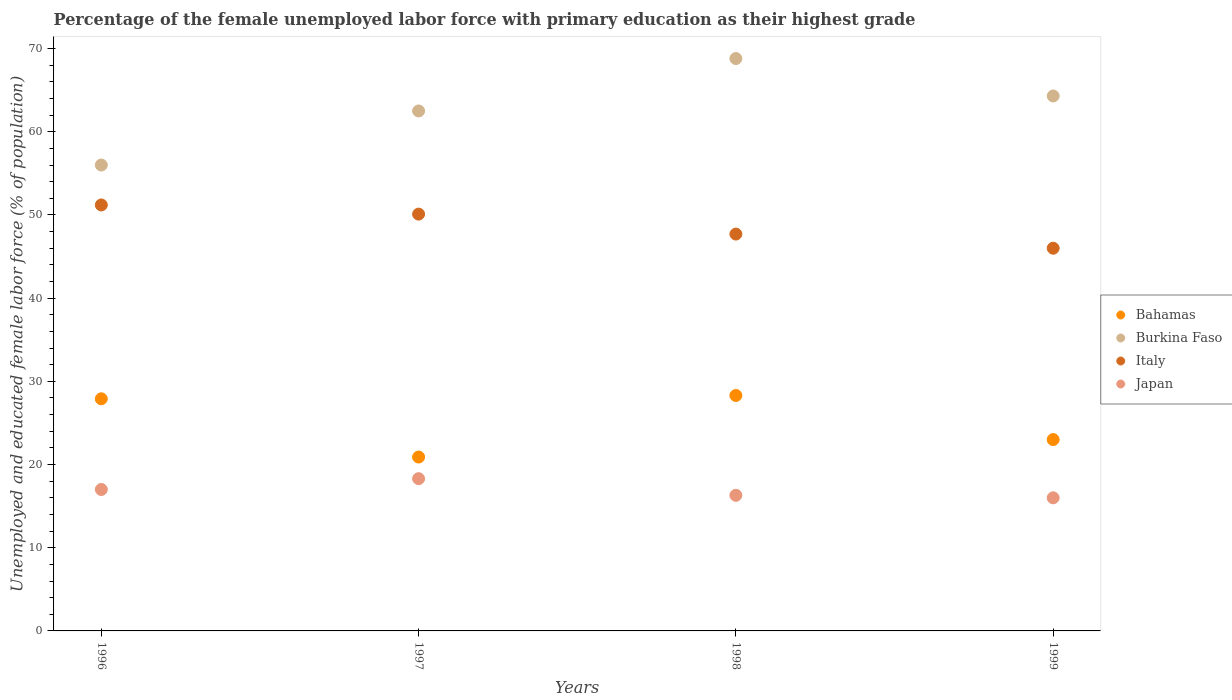Is the number of dotlines equal to the number of legend labels?
Give a very brief answer. Yes. What is the percentage of the unemployed female labor force with primary education in Burkina Faso in 1998?
Your answer should be very brief. 68.8. Across all years, what is the maximum percentage of the unemployed female labor force with primary education in Bahamas?
Provide a succinct answer. 28.3. In which year was the percentage of the unemployed female labor force with primary education in Bahamas maximum?
Your answer should be very brief. 1998. What is the total percentage of the unemployed female labor force with primary education in Italy in the graph?
Keep it short and to the point. 195. What is the difference between the percentage of the unemployed female labor force with primary education in Italy in 1996 and that in 1998?
Provide a short and direct response. 3.5. What is the difference between the percentage of the unemployed female labor force with primary education in Japan in 1997 and the percentage of the unemployed female labor force with primary education in Burkina Faso in 1999?
Offer a very short reply. -46. What is the average percentage of the unemployed female labor force with primary education in Bahamas per year?
Offer a terse response. 25.02. In the year 1996, what is the difference between the percentage of the unemployed female labor force with primary education in Burkina Faso and percentage of the unemployed female labor force with primary education in Bahamas?
Offer a terse response. 28.1. What is the ratio of the percentage of the unemployed female labor force with primary education in Italy in 1997 to that in 1998?
Ensure brevity in your answer.  1.05. Is the percentage of the unemployed female labor force with primary education in Italy in 1996 less than that in 1999?
Your answer should be compact. No. What is the difference between the highest and the second highest percentage of the unemployed female labor force with primary education in Japan?
Your answer should be very brief. 1.3. What is the difference between the highest and the lowest percentage of the unemployed female labor force with primary education in Italy?
Provide a short and direct response. 5.2. In how many years, is the percentage of the unemployed female labor force with primary education in Bahamas greater than the average percentage of the unemployed female labor force with primary education in Bahamas taken over all years?
Keep it short and to the point. 2. Is the percentage of the unemployed female labor force with primary education in Bahamas strictly greater than the percentage of the unemployed female labor force with primary education in Burkina Faso over the years?
Make the answer very short. No. How many years are there in the graph?
Ensure brevity in your answer.  4. What is the difference between two consecutive major ticks on the Y-axis?
Provide a succinct answer. 10. Does the graph contain grids?
Provide a short and direct response. No. Where does the legend appear in the graph?
Offer a terse response. Center right. How are the legend labels stacked?
Your response must be concise. Vertical. What is the title of the graph?
Give a very brief answer. Percentage of the female unemployed labor force with primary education as their highest grade. Does "Palau" appear as one of the legend labels in the graph?
Provide a short and direct response. No. What is the label or title of the Y-axis?
Provide a short and direct response. Unemployed and educated female labor force (% of population). What is the Unemployed and educated female labor force (% of population) of Bahamas in 1996?
Make the answer very short. 27.9. What is the Unemployed and educated female labor force (% of population) in Italy in 1996?
Provide a short and direct response. 51.2. What is the Unemployed and educated female labor force (% of population) in Japan in 1996?
Offer a very short reply. 17. What is the Unemployed and educated female labor force (% of population) of Bahamas in 1997?
Your answer should be very brief. 20.9. What is the Unemployed and educated female labor force (% of population) in Burkina Faso in 1997?
Give a very brief answer. 62.5. What is the Unemployed and educated female labor force (% of population) in Italy in 1997?
Give a very brief answer. 50.1. What is the Unemployed and educated female labor force (% of population) in Japan in 1997?
Provide a succinct answer. 18.3. What is the Unemployed and educated female labor force (% of population) of Bahamas in 1998?
Make the answer very short. 28.3. What is the Unemployed and educated female labor force (% of population) in Burkina Faso in 1998?
Provide a succinct answer. 68.8. What is the Unemployed and educated female labor force (% of population) in Italy in 1998?
Offer a terse response. 47.7. What is the Unemployed and educated female labor force (% of population) of Japan in 1998?
Provide a succinct answer. 16.3. What is the Unemployed and educated female labor force (% of population) in Burkina Faso in 1999?
Provide a succinct answer. 64.3. What is the Unemployed and educated female labor force (% of population) of Italy in 1999?
Provide a short and direct response. 46. Across all years, what is the maximum Unemployed and educated female labor force (% of population) of Bahamas?
Ensure brevity in your answer.  28.3. Across all years, what is the maximum Unemployed and educated female labor force (% of population) of Burkina Faso?
Ensure brevity in your answer.  68.8. Across all years, what is the maximum Unemployed and educated female labor force (% of population) in Italy?
Make the answer very short. 51.2. Across all years, what is the maximum Unemployed and educated female labor force (% of population) of Japan?
Keep it short and to the point. 18.3. Across all years, what is the minimum Unemployed and educated female labor force (% of population) of Bahamas?
Provide a short and direct response. 20.9. Across all years, what is the minimum Unemployed and educated female labor force (% of population) of Burkina Faso?
Offer a terse response. 56. Across all years, what is the minimum Unemployed and educated female labor force (% of population) in Italy?
Offer a terse response. 46. What is the total Unemployed and educated female labor force (% of population) of Bahamas in the graph?
Make the answer very short. 100.1. What is the total Unemployed and educated female labor force (% of population) of Burkina Faso in the graph?
Offer a terse response. 251.6. What is the total Unemployed and educated female labor force (% of population) in Italy in the graph?
Provide a short and direct response. 195. What is the total Unemployed and educated female labor force (% of population) of Japan in the graph?
Offer a very short reply. 67.6. What is the difference between the Unemployed and educated female labor force (% of population) of Bahamas in 1996 and that in 1997?
Offer a terse response. 7. What is the difference between the Unemployed and educated female labor force (% of population) of Burkina Faso in 1996 and that in 1997?
Provide a short and direct response. -6.5. What is the difference between the Unemployed and educated female labor force (% of population) of Italy in 1996 and that in 1997?
Your response must be concise. 1.1. What is the difference between the Unemployed and educated female labor force (% of population) of Japan in 1996 and that in 1997?
Your response must be concise. -1.3. What is the difference between the Unemployed and educated female labor force (% of population) in Bahamas in 1996 and that in 1998?
Give a very brief answer. -0.4. What is the difference between the Unemployed and educated female labor force (% of population) in Italy in 1996 and that in 1998?
Your answer should be compact. 3.5. What is the difference between the Unemployed and educated female labor force (% of population) of Burkina Faso in 1996 and that in 1999?
Keep it short and to the point. -8.3. What is the difference between the Unemployed and educated female labor force (% of population) in Italy in 1996 and that in 1999?
Your answer should be compact. 5.2. What is the difference between the Unemployed and educated female labor force (% of population) of Italy in 1997 and that in 1998?
Offer a terse response. 2.4. What is the difference between the Unemployed and educated female labor force (% of population) in Japan in 1997 and that in 1998?
Provide a succinct answer. 2. What is the difference between the Unemployed and educated female labor force (% of population) in Italy in 1997 and that in 1999?
Offer a very short reply. 4.1. What is the difference between the Unemployed and educated female labor force (% of population) of Japan in 1997 and that in 1999?
Offer a very short reply. 2.3. What is the difference between the Unemployed and educated female labor force (% of population) in Bahamas in 1998 and that in 1999?
Provide a short and direct response. 5.3. What is the difference between the Unemployed and educated female labor force (% of population) of Burkina Faso in 1998 and that in 1999?
Offer a terse response. 4.5. What is the difference between the Unemployed and educated female labor force (% of population) of Japan in 1998 and that in 1999?
Make the answer very short. 0.3. What is the difference between the Unemployed and educated female labor force (% of population) of Bahamas in 1996 and the Unemployed and educated female labor force (% of population) of Burkina Faso in 1997?
Provide a short and direct response. -34.6. What is the difference between the Unemployed and educated female labor force (% of population) of Bahamas in 1996 and the Unemployed and educated female labor force (% of population) of Italy in 1997?
Your answer should be compact. -22.2. What is the difference between the Unemployed and educated female labor force (% of population) in Burkina Faso in 1996 and the Unemployed and educated female labor force (% of population) in Japan in 1997?
Your answer should be compact. 37.7. What is the difference between the Unemployed and educated female labor force (% of population) of Italy in 1996 and the Unemployed and educated female labor force (% of population) of Japan in 1997?
Ensure brevity in your answer.  32.9. What is the difference between the Unemployed and educated female labor force (% of population) in Bahamas in 1996 and the Unemployed and educated female labor force (% of population) in Burkina Faso in 1998?
Your response must be concise. -40.9. What is the difference between the Unemployed and educated female labor force (% of population) of Bahamas in 1996 and the Unemployed and educated female labor force (% of population) of Italy in 1998?
Your answer should be very brief. -19.8. What is the difference between the Unemployed and educated female labor force (% of population) in Burkina Faso in 1996 and the Unemployed and educated female labor force (% of population) in Japan in 1998?
Give a very brief answer. 39.7. What is the difference between the Unemployed and educated female labor force (% of population) of Italy in 1996 and the Unemployed and educated female labor force (% of population) of Japan in 1998?
Offer a very short reply. 34.9. What is the difference between the Unemployed and educated female labor force (% of population) of Bahamas in 1996 and the Unemployed and educated female labor force (% of population) of Burkina Faso in 1999?
Your answer should be very brief. -36.4. What is the difference between the Unemployed and educated female labor force (% of population) in Bahamas in 1996 and the Unemployed and educated female labor force (% of population) in Italy in 1999?
Give a very brief answer. -18.1. What is the difference between the Unemployed and educated female labor force (% of population) in Burkina Faso in 1996 and the Unemployed and educated female labor force (% of population) in Japan in 1999?
Provide a short and direct response. 40. What is the difference between the Unemployed and educated female labor force (% of population) of Italy in 1996 and the Unemployed and educated female labor force (% of population) of Japan in 1999?
Offer a terse response. 35.2. What is the difference between the Unemployed and educated female labor force (% of population) of Bahamas in 1997 and the Unemployed and educated female labor force (% of population) of Burkina Faso in 1998?
Make the answer very short. -47.9. What is the difference between the Unemployed and educated female labor force (% of population) of Bahamas in 1997 and the Unemployed and educated female labor force (% of population) of Italy in 1998?
Offer a very short reply. -26.8. What is the difference between the Unemployed and educated female labor force (% of population) in Burkina Faso in 1997 and the Unemployed and educated female labor force (% of population) in Japan in 1998?
Give a very brief answer. 46.2. What is the difference between the Unemployed and educated female labor force (% of population) of Italy in 1997 and the Unemployed and educated female labor force (% of population) of Japan in 1998?
Offer a terse response. 33.8. What is the difference between the Unemployed and educated female labor force (% of population) in Bahamas in 1997 and the Unemployed and educated female labor force (% of population) in Burkina Faso in 1999?
Give a very brief answer. -43.4. What is the difference between the Unemployed and educated female labor force (% of population) of Bahamas in 1997 and the Unemployed and educated female labor force (% of population) of Italy in 1999?
Make the answer very short. -25.1. What is the difference between the Unemployed and educated female labor force (% of population) of Bahamas in 1997 and the Unemployed and educated female labor force (% of population) of Japan in 1999?
Provide a succinct answer. 4.9. What is the difference between the Unemployed and educated female labor force (% of population) in Burkina Faso in 1997 and the Unemployed and educated female labor force (% of population) in Japan in 1999?
Make the answer very short. 46.5. What is the difference between the Unemployed and educated female labor force (% of population) of Italy in 1997 and the Unemployed and educated female labor force (% of population) of Japan in 1999?
Give a very brief answer. 34.1. What is the difference between the Unemployed and educated female labor force (% of population) in Bahamas in 1998 and the Unemployed and educated female labor force (% of population) in Burkina Faso in 1999?
Your answer should be compact. -36. What is the difference between the Unemployed and educated female labor force (% of population) of Bahamas in 1998 and the Unemployed and educated female labor force (% of population) of Italy in 1999?
Provide a succinct answer. -17.7. What is the difference between the Unemployed and educated female labor force (% of population) in Burkina Faso in 1998 and the Unemployed and educated female labor force (% of population) in Italy in 1999?
Offer a very short reply. 22.8. What is the difference between the Unemployed and educated female labor force (% of population) of Burkina Faso in 1998 and the Unemployed and educated female labor force (% of population) of Japan in 1999?
Ensure brevity in your answer.  52.8. What is the difference between the Unemployed and educated female labor force (% of population) of Italy in 1998 and the Unemployed and educated female labor force (% of population) of Japan in 1999?
Your answer should be compact. 31.7. What is the average Unemployed and educated female labor force (% of population) of Bahamas per year?
Provide a succinct answer. 25.02. What is the average Unemployed and educated female labor force (% of population) of Burkina Faso per year?
Make the answer very short. 62.9. What is the average Unemployed and educated female labor force (% of population) in Italy per year?
Your response must be concise. 48.75. What is the average Unemployed and educated female labor force (% of population) of Japan per year?
Your answer should be compact. 16.9. In the year 1996, what is the difference between the Unemployed and educated female labor force (% of population) of Bahamas and Unemployed and educated female labor force (% of population) of Burkina Faso?
Provide a succinct answer. -28.1. In the year 1996, what is the difference between the Unemployed and educated female labor force (% of population) in Bahamas and Unemployed and educated female labor force (% of population) in Italy?
Offer a terse response. -23.3. In the year 1996, what is the difference between the Unemployed and educated female labor force (% of population) of Burkina Faso and Unemployed and educated female labor force (% of population) of Japan?
Provide a succinct answer. 39. In the year 1996, what is the difference between the Unemployed and educated female labor force (% of population) of Italy and Unemployed and educated female labor force (% of population) of Japan?
Keep it short and to the point. 34.2. In the year 1997, what is the difference between the Unemployed and educated female labor force (% of population) of Bahamas and Unemployed and educated female labor force (% of population) of Burkina Faso?
Your answer should be compact. -41.6. In the year 1997, what is the difference between the Unemployed and educated female labor force (% of population) of Bahamas and Unemployed and educated female labor force (% of population) of Italy?
Give a very brief answer. -29.2. In the year 1997, what is the difference between the Unemployed and educated female labor force (% of population) of Burkina Faso and Unemployed and educated female labor force (% of population) of Japan?
Give a very brief answer. 44.2. In the year 1997, what is the difference between the Unemployed and educated female labor force (% of population) of Italy and Unemployed and educated female labor force (% of population) of Japan?
Give a very brief answer. 31.8. In the year 1998, what is the difference between the Unemployed and educated female labor force (% of population) of Bahamas and Unemployed and educated female labor force (% of population) of Burkina Faso?
Keep it short and to the point. -40.5. In the year 1998, what is the difference between the Unemployed and educated female labor force (% of population) in Bahamas and Unemployed and educated female labor force (% of population) in Italy?
Offer a terse response. -19.4. In the year 1998, what is the difference between the Unemployed and educated female labor force (% of population) in Burkina Faso and Unemployed and educated female labor force (% of population) in Italy?
Offer a terse response. 21.1. In the year 1998, what is the difference between the Unemployed and educated female labor force (% of population) in Burkina Faso and Unemployed and educated female labor force (% of population) in Japan?
Keep it short and to the point. 52.5. In the year 1998, what is the difference between the Unemployed and educated female labor force (% of population) of Italy and Unemployed and educated female labor force (% of population) of Japan?
Provide a succinct answer. 31.4. In the year 1999, what is the difference between the Unemployed and educated female labor force (% of population) in Bahamas and Unemployed and educated female labor force (% of population) in Burkina Faso?
Make the answer very short. -41.3. In the year 1999, what is the difference between the Unemployed and educated female labor force (% of population) in Bahamas and Unemployed and educated female labor force (% of population) in Japan?
Offer a very short reply. 7. In the year 1999, what is the difference between the Unemployed and educated female labor force (% of population) of Burkina Faso and Unemployed and educated female labor force (% of population) of Italy?
Provide a short and direct response. 18.3. In the year 1999, what is the difference between the Unemployed and educated female labor force (% of population) in Burkina Faso and Unemployed and educated female labor force (% of population) in Japan?
Make the answer very short. 48.3. What is the ratio of the Unemployed and educated female labor force (% of population) in Bahamas in 1996 to that in 1997?
Your answer should be compact. 1.33. What is the ratio of the Unemployed and educated female labor force (% of population) of Burkina Faso in 1996 to that in 1997?
Offer a very short reply. 0.9. What is the ratio of the Unemployed and educated female labor force (% of population) of Italy in 1996 to that in 1997?
Provide a short and direct response. 1.02. What is the ratio of the Unemployed and educated female labor force (% of population) in Japan in 1996 to that in 1997?
Offer a very short reply. 0.93. What is the ratio of the Unemployed and educated female labor force (% of population) in Bahamas in 1996 to that in 1998?
Your answer should be very brief. 0.99. What is the ratio of the Unemployed and educated female labor force (% of population) of Burkina Faso in 1996 to that in 1998?
Your answer should be compact. 0.81. What is the ratio of the Unemployed and educated female labor force (% of population) of Italy in 1996 to that in 1998?
Your response must be concise. 1.07. What is the ratio of the Unemployed and educated female labor force (% of population) in Japan in 1996 to that in 1998?
Your response must be concise. 1.04. What is the ratio of the Unemployed and educated female labor force (% of population) in Bahamas in 1996 to that in 1999?
Make the answer very short. 1.21. What is the ratio of the Unemployed and educated female labor force (% of population) of Burkina Faso in 1996 to that in 1999?
Offer a terse response. 0.87. What is the ratio of the Unemployed and educated female labor force (% of population) of Italy in 1996 to that in 1999?
Provide a succinct answer. 1.11. What is the ratio of the Unemployed and educated female labor force (% of population) in Japan in 1996 to that in 1999?
Ensure brevity in your answer.  1.06. What is the ratio of the Unemployed and educated female labor force (% of population) in Bahamas in 1997 to that in 1998?
Give a very brief answer. 0.74. What is the ratio of the Unemployed and educated female labor force (% of population) of Burkina Faso in 1997 to that in 1998?
Offer a very short reply. 0.91. What is the ratio of the Unemployed and educated female labor force (% of population) in Italy in 1997 to that in 1998?
Provide a short and direct response. 1.05. What is the ratio of the Unemployed and educated female labor force (% of population) of Japan in 1997 to that in 1998?
Ensure brevity in your answer.  1.12. What is the ratio of the Unemployed and educated female labor force (% of population) in Bahamas in 1997 to that in 1999?
Make the answer very short. 0.91. What is the ratio of the Unemployed and educated female labor force (% of population) of Burkina Faso in 1997 to that in 1999?
Offer a very short reply. 0.97. What is the ratio of the Unemployed and educated female labor force (% of population) in Italy in 1997 to that in 1999?
Your response must be concise. 1.09. What is the ratio of the Unemployed and educated female labor force (% of population) of Japan in 1997 to that in 1999?
Keep it short and to the point. 1.14. What is the ratio of the Unemployed and educated female labor force (% of population) of Bahamas in 1998 to that in 1999?
Keep it short and to the point. 1.23. What is the ratio of the Unemployed and educated female labor force (% of population) in Burkina Faso in 1998 to that in 1999?
Make the answer very short. 1.07. What is the ratio of the Unemployed and educated female labor force (% of population) of Japan in 1998 to that in 1999?
Make the answer very short. 1.02. What is the difference between the highest and the lowest Unemployed and educated female labor force (% of population) of Bahamas?
Give a very brief answer. 7.4. What is the difference between the highest and the lowest Unemployed and educated female labor force (% of population) of Italy?
Make the answer very short. 5.2. 